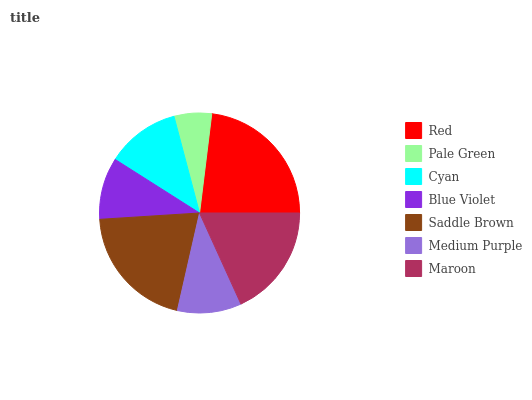Is Pale Green the minimum?
Answer yes or no. Yes. Is Red the maximum?
Answer yes or no. Yes. Is Cyan the minimum?
Answer yes or no. No. Is Cyan the maximum?
Answer yes or no. No. Is Cyan greater than Pale Green?
Answer yes or no. Yes. Is Pale Green less than Cyan?
Answer yes or no. Yes. Is Pale Green greater than Cyan?
Answer yes or no. No. Is Cyan less than Pale Green?
Answer yes or no. No. Is Cyan the high median?
Answer yes or no. Yes. Is Cyan the low median?
Answer yes or no. Yes. Is Red the high median?
Answer yes or no. No. Is Maroon the low median?
Answer yes or no. No. 